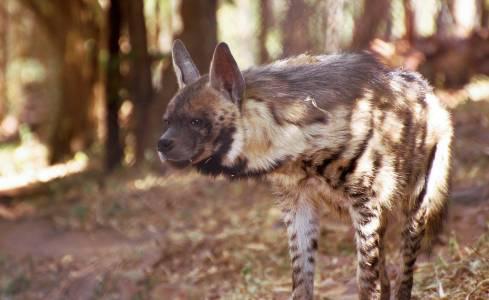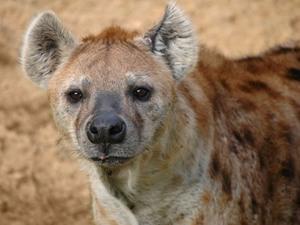The first image is the image on the left, the second image is the image on the right. Evaluate the accuracy of this statement regarding the images: "Some of the hyenas are laying down.". Is it true? Answer yes or no. No. 